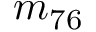Convert formula to latex. <formula><loc_0><loc_0><loc_500><loc_500>m _ { 7 6 }</formula> 